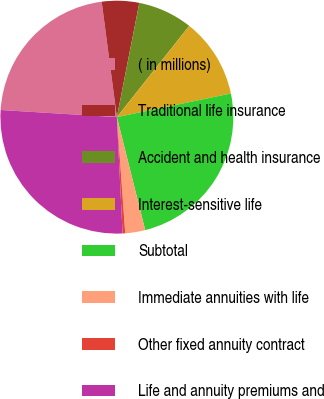Convert chart to OTSL. <chart><loc_0><loc_0><loc_500><loc_500><pie_chart><fcel>( in millions)<fcel>Traditional life insurance<fcel>Accident and health insurance<fcel>Interest-sensitive life<fcel>Subtotal<fcel>Immediate annuities with life<fcel>Other fixed annuity contract<fcel>Life and annuity premiums and<nl><fcel>21.94%<fcel>5.17%<fcel>7.58%<fcel>11.08%<fcel>24.35%<fcel>2.77%<fcel>0.36%<fcel>26.76%<nl></chart> 